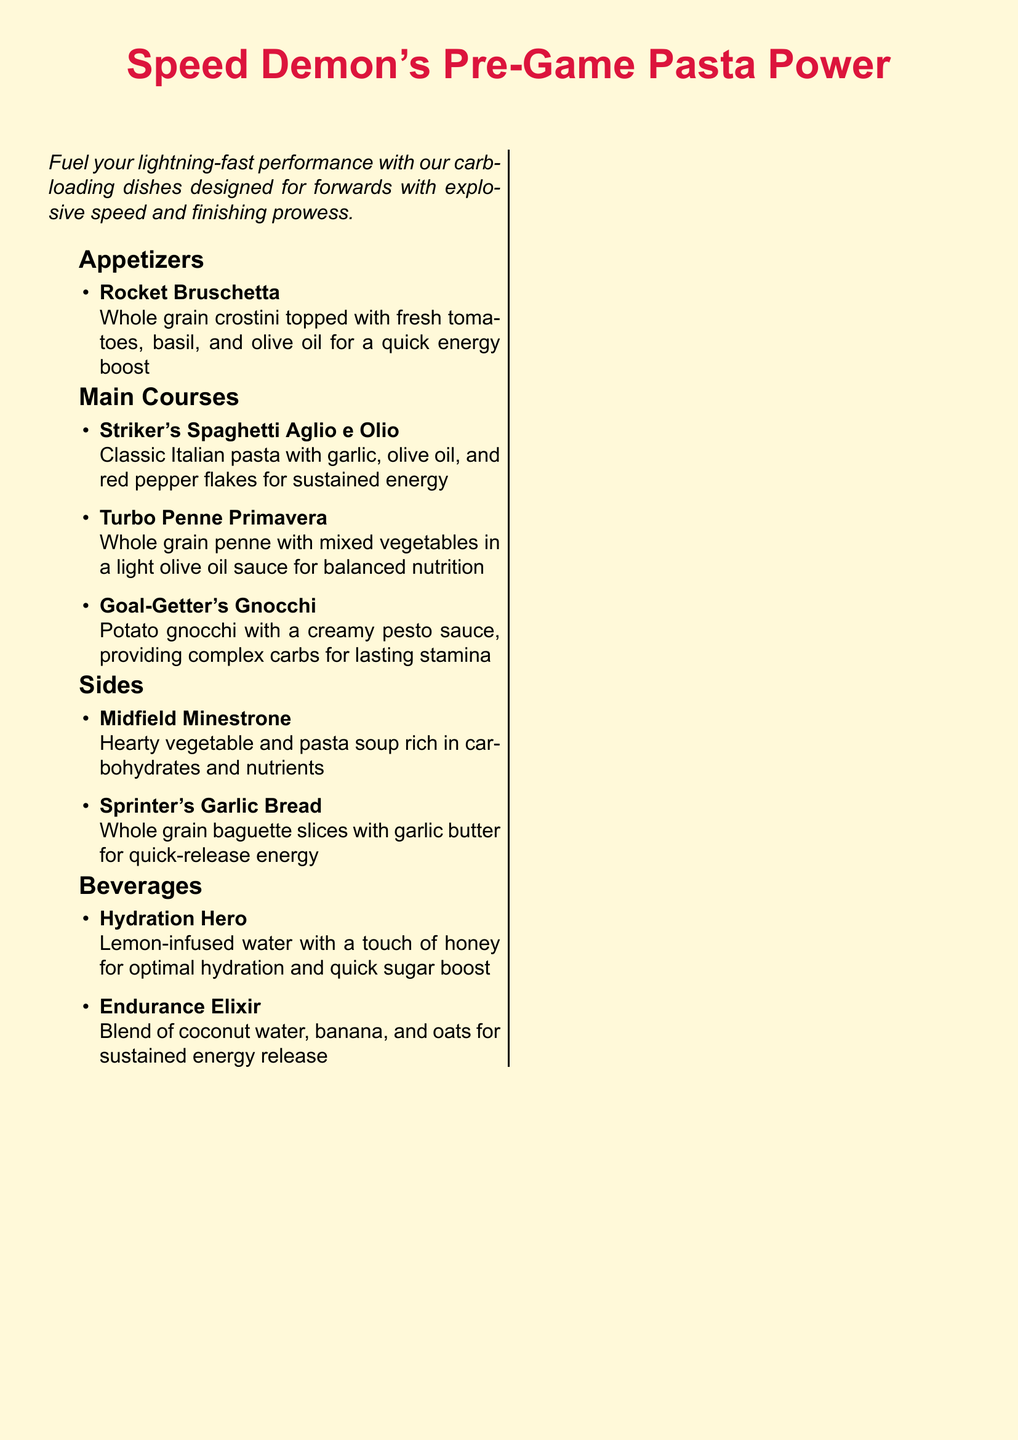what is the title of the menu? The title is prominently displayed at the top of the document in a large font, reading "Speed Demon's Pre-Game Pasta Power."
Answer: Speed Demon's Pre-Game Pasta Power what is the first appetizer listed? The first item under the appetizers section is clearly mentioned as "Rocket Bruschetta."
Answer: Rocket Bruschetta how many main courses are offered? The document lists three distinct main courses which can be counted.
Answer: 3 which dish provides complex carbs for lasting stamina? The text explicitly states that "Goal-Getter's Gnocchi" provides complex carbs for lasting stamina.
Answer: Goal-Getter's Gnocchi what is included in the Endurance Elixir? The ingredients for this beverage are combined in the description, mentioning coconut water, banana, and oats.
Answer: coconut water, banana, and oats what type of bread is used for the Sprinter's Garlic Bread? The description specifies "whole grain baguette slices" for the garlic bread.
Answer: whole grain baguette slices which side dish is rich in carbohydrates and nutrients? The minestrone soup is described as hearty and rich in carbohydrates and nutrients.
Answer: Midfield Minestrone what is the main purpose of these dishes? The introduction states the main purpose clearly as providing optimal carbohydrate intake for pre-game energy.
Answer: optimal carbohydrate intake for pre-game energy 